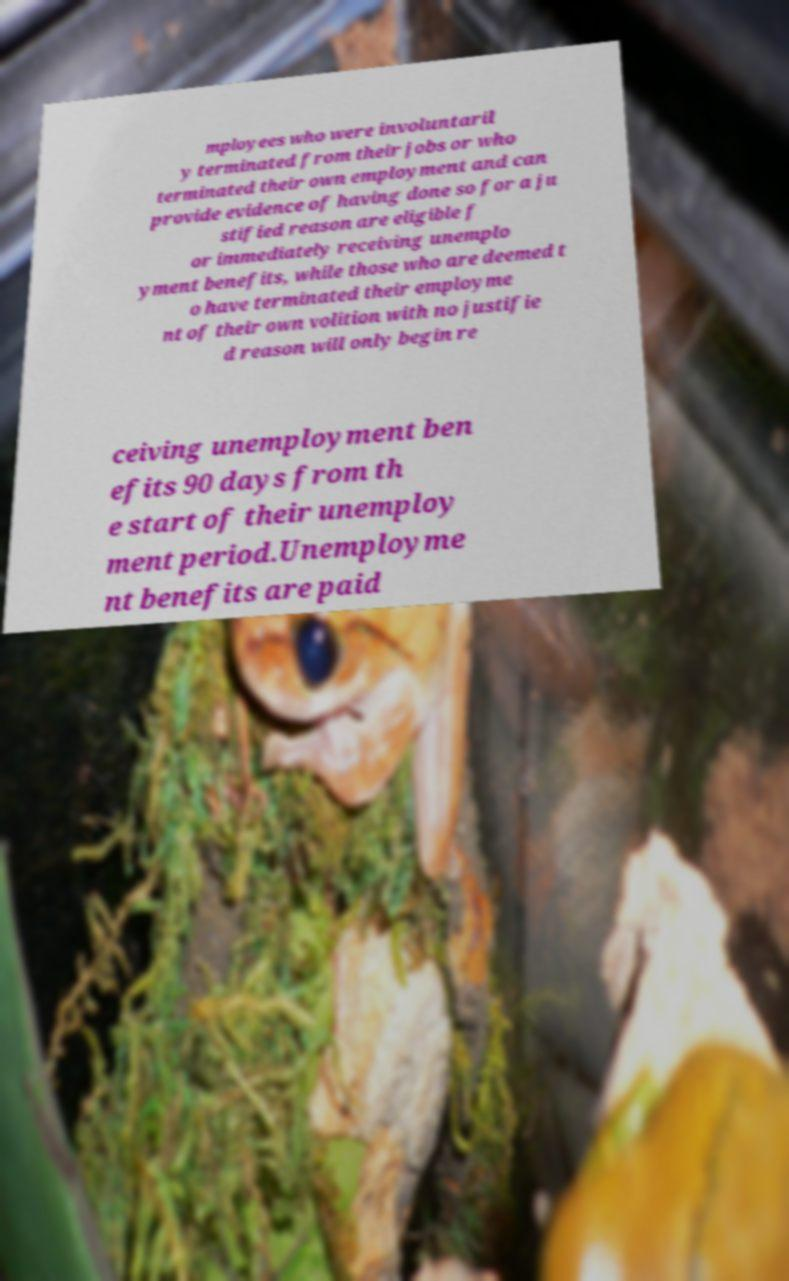Can you accurately transcribe the text from the provided image for me? mployees who were involuntaril y terminated from their jobs or who terminated their own employment and can provide evidence of having done so for a ju stified reason are eligible f or immediately receiving unemplo yment benefits, while those who are deemed t o have terminated their employme nt of their own volition with no justifie d reason will only begin re ceiving unemployment ben efits 90 days from th e start of their unemploy ment period.Unemployme nt benefits are paid 